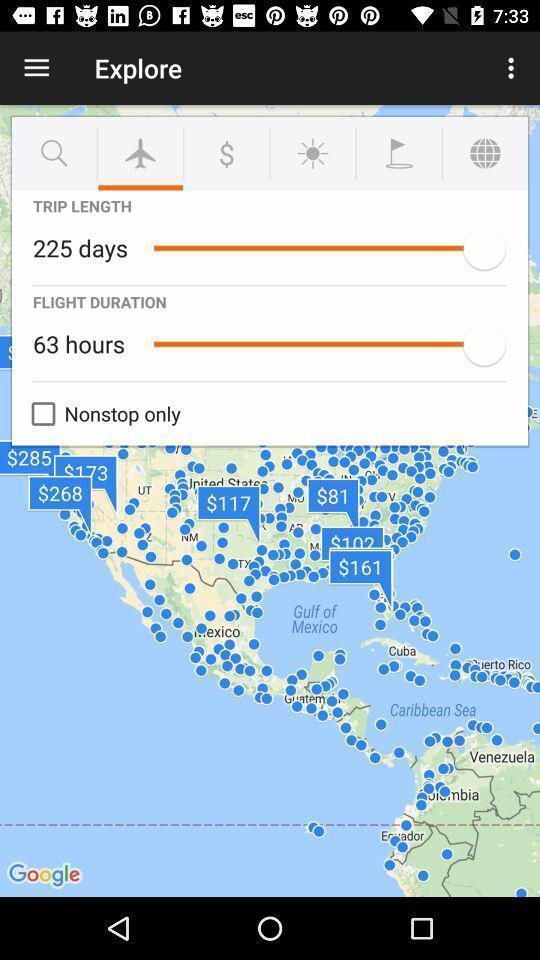Give me a summary of this screen capture. Pop up with time and hours of travel. 